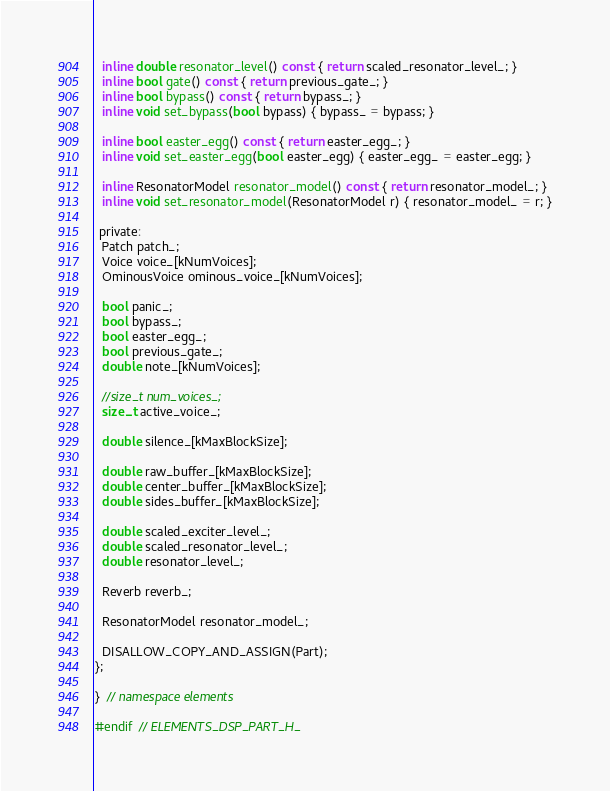Convert code to text. <code><loc_0><loc_0><loc_500><loc_500><_C_>  inline double resonator_level() const { return scaled_resonator_level_; }
  inline bool gate() const { return previous_gate_; }
  inline bool bypass() const { return bypass_; }
  inline void set_bypass(bool bypass) { bypass_ = bypass; }

  inline bool easter_egg() const { return easter_egg_; }
  inline void set_easter_egg(bool easter_egg) { easter_egg_ = easter_egg; }

  inline ResonatorModel resonator_model() const { return resonator_model_; }
  inline void set_resonator_model(ResonatorModel r) { resonator_model_ = r; }
    
 private:
  Patch patch_;
  Voice voice_[kNumVoices];
  OminousVoice ominous_voice_[kNumVoices];
  
  bool panic_;
  bool bypass_;
  bool easter_egg_;
  bool previous_gate_;
  double note_[kNumVoices];
  
  //size_t num_voices_;
  size_t active_voice_;
  
  double silence_[kMaxBlockSize];
  
  double raw_buffer_[kMaxBlockSize];
  double center_buffer_[kMaxBlockSize];
  double sides_buffer_[kMaxBlockSize];
  
  double scaled_exciter_level_;
  double scaled_resonator_level_;
  double resonator_level_;
  
  Reverb reverb_;
  
  ResonatorModel resonator_model_;
  
  DISALLOW_COPY_AND_ASSIGN(Part);
};

}  // namespace elements

#endif  // ELEMENTS_DSP_PART_H_
</code> 